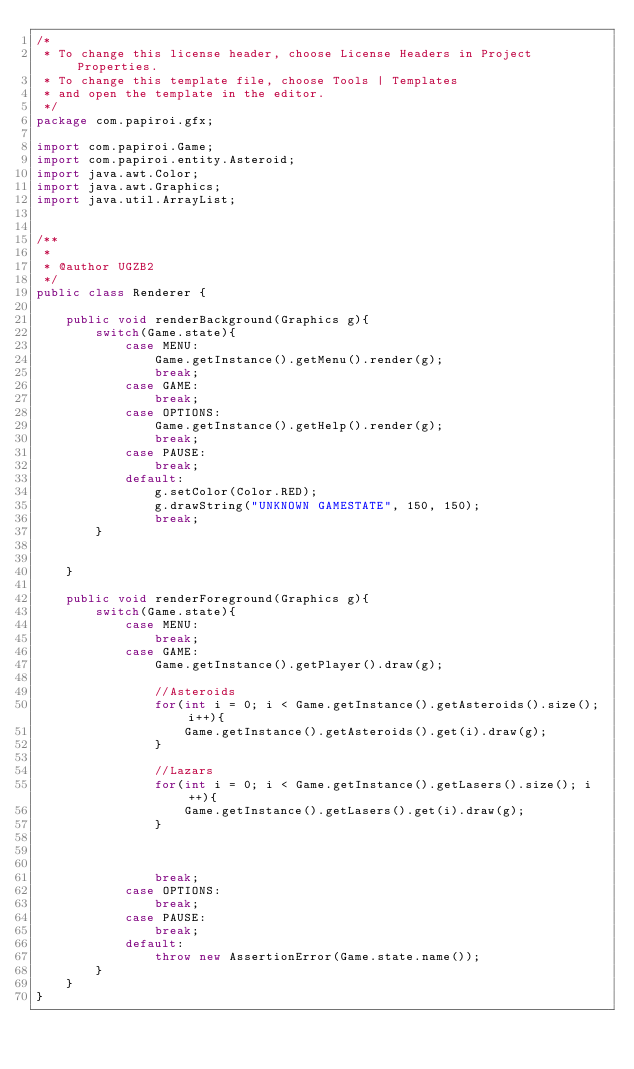<code> <loc_0><loc_0><loc_500><loc_500><_Java_>/*
 * To change this license header, choose License Headers in Project Properties.
 * To change this template file, choose Tools | Templates
 * and open the template in the editor.
 */
package com.papiroi.gfx;

import com.papiroi.Game;
import com.papiroi.entity.Asteroid;
import java.awt.Color;
import java.awt.Graphics;
import java.util.ArrayList;


/**
 *
 * @author UGZB2
 */
public class Renderer {
    
    public void renderBackground(Graphics g){
        switch(Game.state){
            case MENU:
                Game.getInstance().getMenu().render(g);
                break;
            case GAME:
                break;
            case OPTIONS:
                Game.getInstance().getHelp().render(g);
                break;
            case PAUSE:
                break;
            default:
                g.setColor(Color.RED);
                g.drawString("UNKNOWN GAMESTATE", 150, 150);
                break;
        }
        
        
    }
    
    public void renderForeground(Graphics g){
        switch(Game.state){
            case MENU:
                break;
            case GAME:
                Game.getInstance().getPlayer().draw(g);
                
                //Asteroids
                for(int i = 0; i < Game.getInstance().getAsteroids().size(); i++){
                    Game.getInstance().getAsteroids().get(i).draw(g);
                }
                
                //Lazars
                for(int i = 0; i < Game.getInstance().getLasers().size(); i++){
                    Game.getInstance().getLasers().get(i).draw(g);
                }
                
                
                
                break;
            case OPTIONS:
                break;
            case PAUSE:
                break;
            default:
                throw new AssertionError(Game.state.name());
        }
    }   
}
    

</code> 